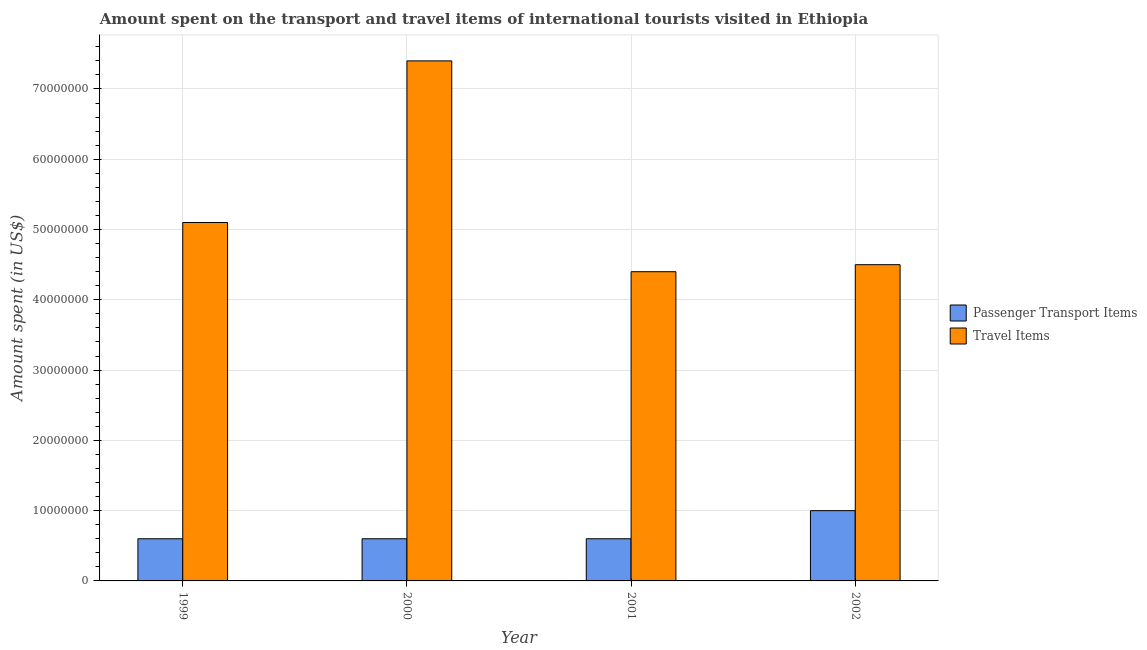How many different coloured bars are there?
Your answer should be very brief. 2. How many groups of bars are there?
Offer a very short reply. 4. Are the number of bars per tick equal to the number of legend labels?
Offer a very short reply. Yes. Are the number of bars on each tick of the X-axis equal?
Make the answer very short. Yes. What is the label of the 1st group of bars from the left?
Ensure brevity in your answer.  1999. What is the amount spent on passenger transport items in 2001?
Ensure brevity in your answer.  6.00e+06. Across all years, what is the maximum amount spent in travel items?
Your answer should be compact. 7.40e+07. Across all years, what is the minimum amount spent on passenger transport items?
Give a very brief answer. 6.00e+06. What is the total amount spent in travel items in the graph?
Your answer should be very brief. 2.14e+08. What is the average amount spent on passenger transport items per year?
Provide a succinct answer. 7.00e+06. In how many years, is the amount spent in travel items greater than 34000000 US$?
Give a very brief answer. 4. Is the difference between the amount spent on passenger transport items in 1999 and 2001 greater than the difference between the amount spent in travel items in 1999 and 2001?
Make the answer very short. No. What is the difference between the highest and the second highest amount spent on passenger transport items?
Give a very brief answer. 4.00e+06. What is the difference between the highest and the lowest amount spent on passenger transport items?
Ensure brevity in your answer.  4.00e+06. Is the sum of the amount spent on passenger transport items in 2000 and 2001 greater than the maximum amount spent in travel items across all years?
Ensure brevity in your answer.  Yes. What does the 1st bar from the left in 2000 represents?
Offer a very short reply. Passenger Transport Items. What does the 1st bar from the right in 1999 represents?
Ensure brevity in your answer.  Travel Items. How many bars are there?
Offer a very short reply. 8. Are all the bars in the graph horizontal?
Make the answer very short. No. Are the values on the major ticks of Y-axis written in scientific E-notation?
Ensure brevity in your answer.  No. How many legend labels are there?
Your response must be concise. 2. How are the legend labels stacked?
Offer a terse response. Vertical. What is the title of the graph?
Keep it short and to the point. Amount spent on the transport and travel items of international tourists visited in Ethiopia. Does "Study and work" appear as one of the legend labels in the graph?
Your answer should be compact. No. What is the label or title of the Y-axis?
Your answer should be very brief. Amount spent (in US$). What is the Amount spent (in US$) in Passenger Transport Items in 1999?
Offer a terse response. 6.00e+06. What is the Amount spent (in US$) of Travel Items in 1999?
Your answer should be compact. 5.10e+07. What is the Amount spent (in US$) in Travel Items in 2000?
Offer a terse response. 7.40e+07. What is the Amount spent (in US$) of Passenger Transport Items in 2001?
Offer a terse response. 6.00e+06. What is the Amount spent (in US$) in Travel Items in 2001?
Your response must be concise. 4.40e+07. What is the Amount spent (in US$) in Passenger Transport Items in 2002?
Offer a very short reply. 1.00e+07. What is the Amount spent (in US$) of Travel Items in 2002?
Your response must be concise. 4.50e+07. Across all years, what is the maximum Amount spent (in US$) of Travel Items?
Your answer should be compact. 7.40e+07. Across all years, what is the minimum Amount spent (in US$) of Travel Items?
Ensure brevity in your answer.  4.40e+07. What is the total Amount spent (in US$) of Passenger Transport Items in the graph?
Ensure brevity in your answer.  2.80e+07. What is the total Amount spent (in US$) in Travel Items in the graph?
Provide a short and direct response. 2.14e+08. What is the difference between the Amount spent (in US$) of Travel Items in 1999 and that in 2000?
Provide a succinct answer. -2.30e+07. What is the difference between the Amount spent (in US$) of Travel Items in 1999 and that in 2001?
Offer a terse response. 7.00e+06. What is the difference between the Amount spent (in US$) of Passenger Transport Items in 1999 and that in 2002?
Keep it short and to the point. -4.00e+06. What is the difference between the Amount spent (in US$) of Travel Items in 1999 and that in 2002?
Ensure brevity in your answer.  6.00e+06. What is the difference between the Amount spent (in US$) of Travel Items in 2000 and that in 2001?
Your answer should be very brief. 3.00e+07. What is the difference between the Amount spent (in US$) of Passenger Transport Items in 2000 and that in 2002?
Make the answer very short. -4.00e+06. What is the difference between the Amount spent (in US$) in Travel Items in 2000 and that in 2002?
Make the answer very short. 2.90e+07. What is the difference between the Amount spent (in US$) of Passenger Transport Items in 2001 and that in 2002?
Your response must be concise. -4.00e+06. What is the difference between the Amount spent (in US$) in Passenger Transport Items in 1999 and the Amount spent (in US$) in Travel Items in 2000?
Provide a succinct answer. -6.80e+07. What is the difference between the Amount spent (in US$) of Passenger Transport Items in 1999 and the Amount spent (in US$) of Travel Items in 2001?
Provide a short and direct response. -3.80e+07. What is the difference between the Amount spent (in US$) of Passenger Transport Items in 1999 and the Amount spent (in US$) of Travel Items in 2002?
Make the answer very short. -3.90e+07. What is the difference between the Amount spent (in US$) of Passenger Transport Items in 2000 and the Amount spent (in US$) of Travel Items in 2001?
Provide a succinct answer. -3.80e+07. What is the difference between the Amount spent (in US$) in Passenger Transport Items in 2000 and the Amount spent (in US$) in Travel Items in 2002?
Provide a short and direct response. -3.90e+07. What is the difference between the Amount spent (in US$) of Passenger Transport Items in 2001 and the Amount spent (in US$) of Travel Items in 2002?
Ensure brevity in your answer.  -3.90e+07. What is the average Amount spent (in US$) in Passenger Transport Items per year?
Offer a terse response. 7.00e+06. What is the average Amount spent (in US$) of Travel Items per year?
Give a very brief answer. 5.35e+07. In the year 1999, what is the difference between the Amount spent (in US$) in Passenger Transport Items and Amount spent (in US$) in Travel Items?
Keep it short and to the point. -4.50e+07. In the year 2000, what is the difference between the Amount spent (in US$) of Passenger Transport Items and Amount spent (in US$) of Travel Items?
Your answer should be very brief. -6.80e+07. In the year 2001, what is the difference between the Amount spent (in US$) of Passenger Transport Items and Amount spent (in US$) of Travel Items?
Your answer should be compact. -3.80e+07. In the year 2002, what is the difference between the Amount spent (in US$) of Passenger Transport Items and Amount spent (in US$) of Travel Items?
Provide a succinct answer. -3.50e+07. What is the ratio of the Amount spent (in US$) in Travel Items in 1999 to that in 2000?
Your response must be concise. 0.69. What is the ratio of the Amount spent (in US$) in Passenger Transport Items in 1999 to that in 2001?
Ensure brevity in your answer.  1. What is the ratio of the Amount spent (in US$) in Travel Items in 1999 to that in 2001?
Your response must be concise. 1.16. What is the ratio of the Amount spent (in US$) of Passenger Transport Items in 1999 to that in 2002?
Your answer should be compact. 0.6. What is the ratio of the Amount spent (in US$) of Travel Items in 1999 to that in 2002?
Provide a succinct answer. 1.13. What is the ratio of the Amount spent (in US$) in Travel Items in 2000 to that in 2001?
Provide a succinct answer. 1.68. What is the ratio of the Amount spent (in US$) of Passenger Transport Items in 2000 to that in 2002?
Keep it short and to the point. 0.6. What is the ratio of the Amount spent (in US$) of Travel Items in 2000 to that in 2002?
Ensure brevity in your answer.  1.64. What is the ratio of the Amount spent (in US$) of Passenger Transport Items in 2001 to that in 2002?
Provide a succinct answer. 0.6. What is the ratio of the Amount spent (in US$) in Travel Items in 2001 to that in 2002?
Your answer should be compact. 0.98. What is the difference between the highest and the second highest Amount spent (in US$) in Travel Items?
Make the answer very short. 2.30e+07. What is the difference between the highest and the lowest Amount spent (in US$) of Travel Items?
Provide a short and direct response. 3.00e+07. 